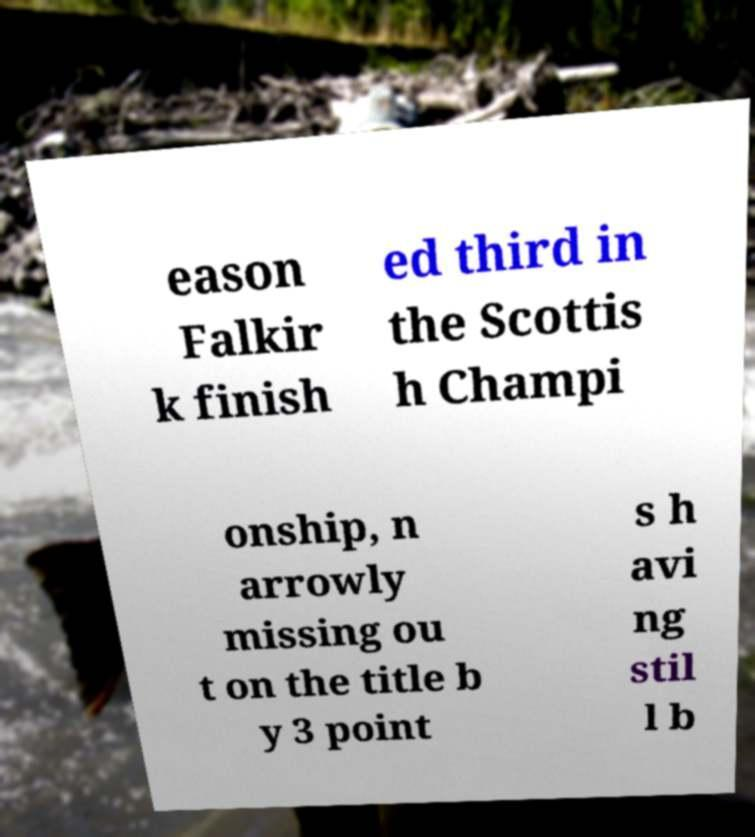There's text embedded in this image that I need extracted. Can you transcribe it verbatim? eason Falkir k finish ed third in the Scottis h Champi onship, n arrowly missing ou t on the title b y 3 point s h avi ng stil l b 